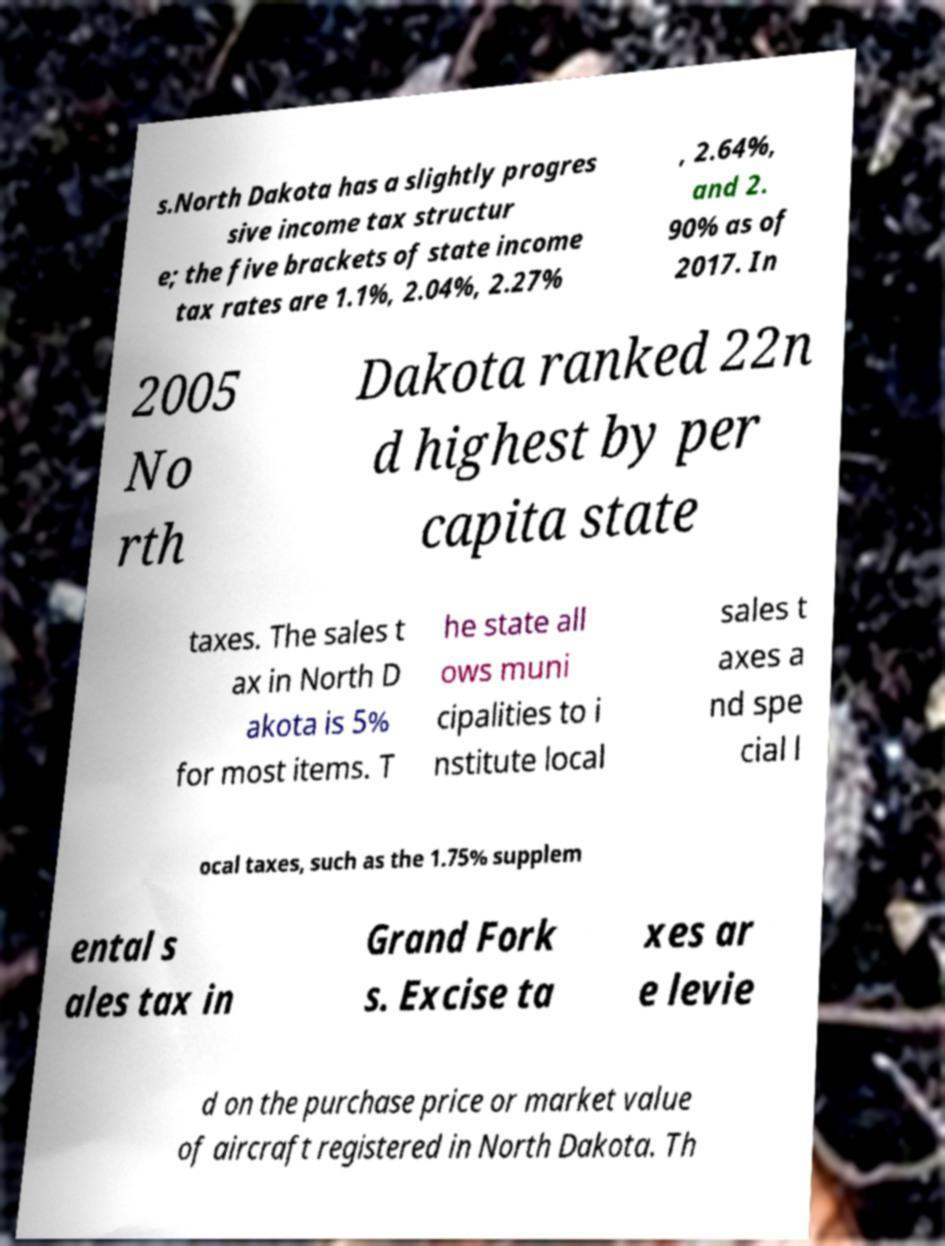Please identify and transcribe the text found in this image. s.North Dakota has a slightly progres sive income tax structur e; the five brackets of state income tax rates are 1.1%, 2.04%, 2.27% , 2.64%, and 2. 90% as of 2017. In 2005 No rth Dakota ranked 22n d highest by per capita state taxes. The sales t ax in North D akota is 5% for most items. T he state all ows muni cipalities to i nstitute local sales t axes a nd spe cial l ocal taxes, such as the 1.75% supplem ental s ales tax in Grand Fork s. Excise ta xes ar e levie d on the purchase price or market value of aircraft registered in North Dakota. Th 